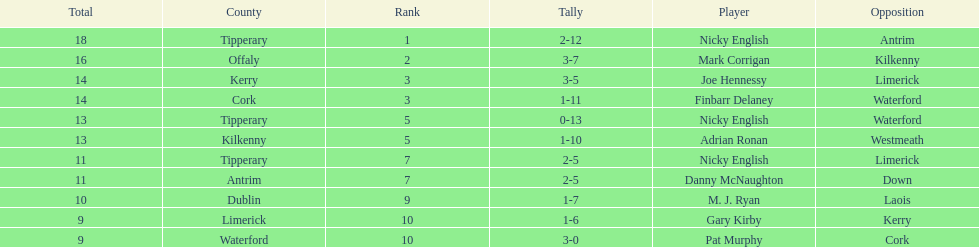How many people are on the list? 9. 